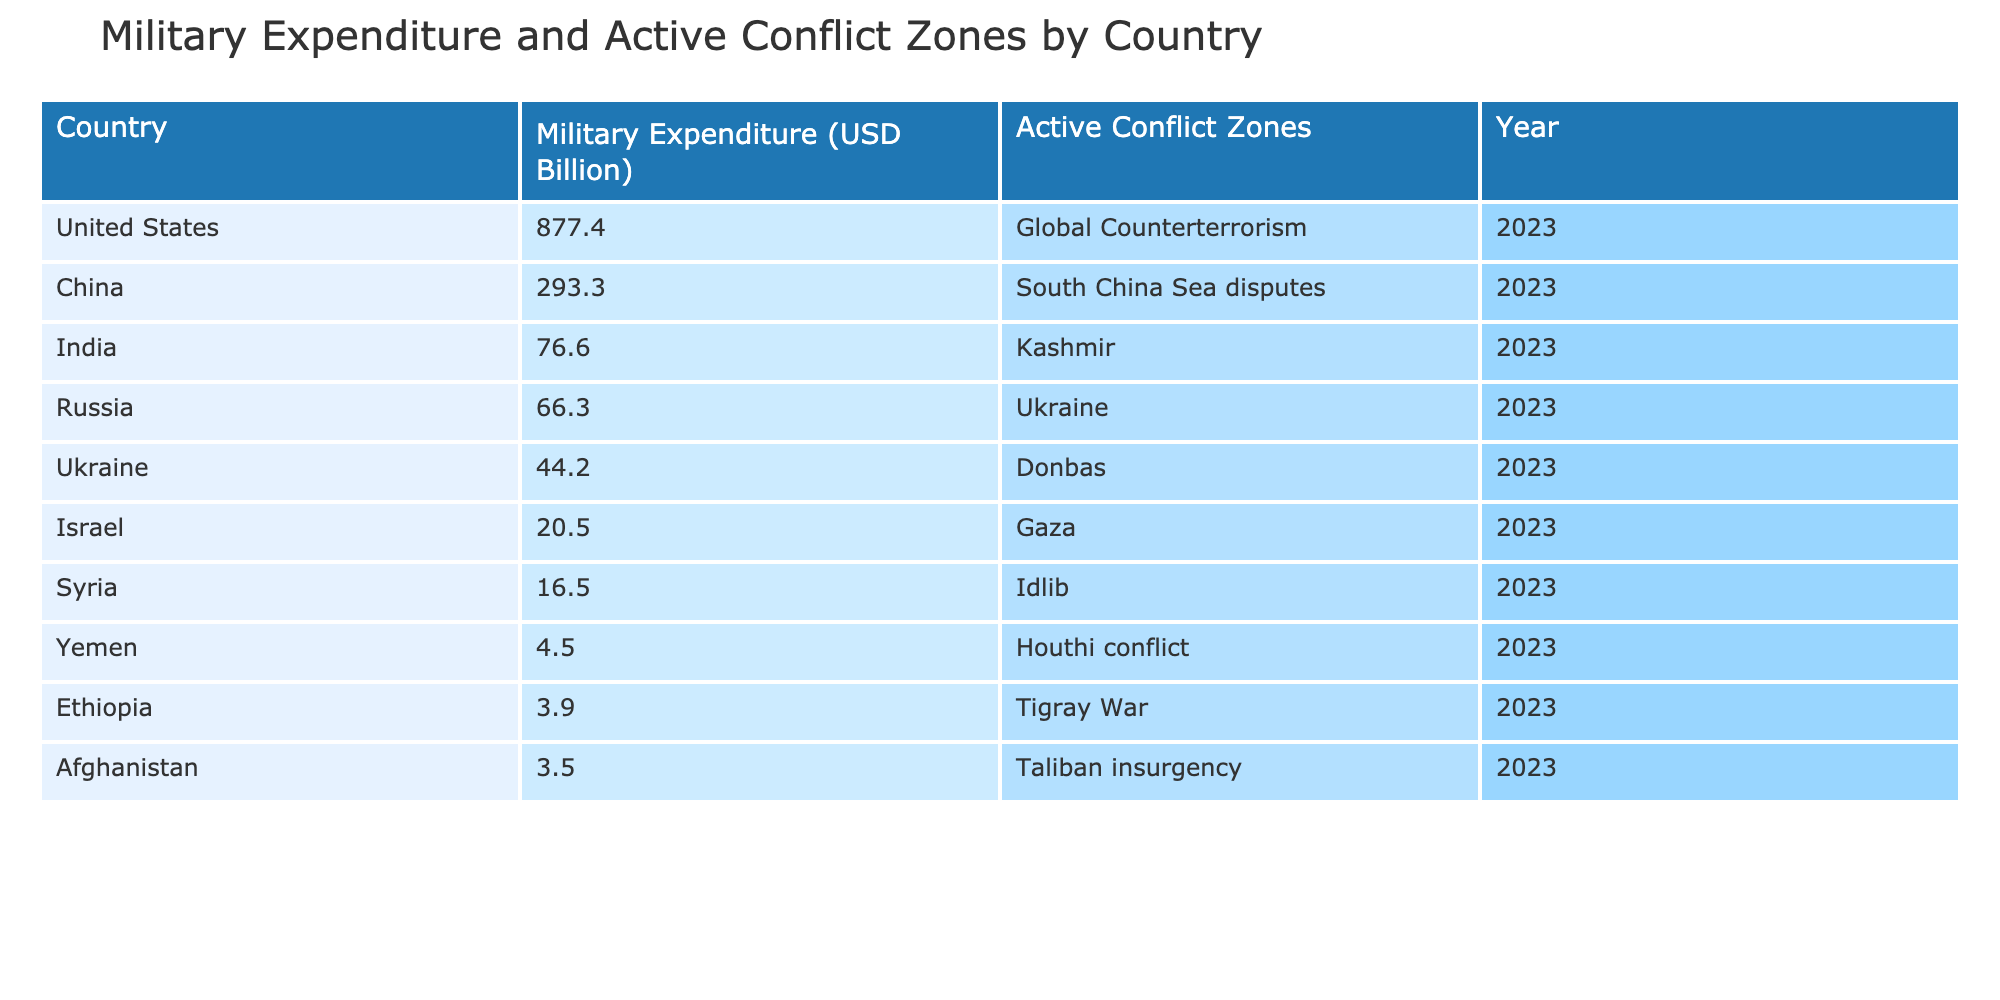What country has the highest military expenditure? The country with the highest military expenditure is the United States, with a figure of 877.4 billion USD. This value is retrieved directly from the table, identifying the maximum expenditure listed.
Answer: United States What is the military expenditure of Ukraine in 2023? Ukraine's military expenditure for the year 2023 is 44.2 billion USD, as can be found in the respective row of the table.
Answer: 44.2 billion USD How much more does China spend on military than Ethiopia? China's military expenditure is 293.3 billion USD, while Ethiopia's is 3.9 billion USD. The difference is calculated as 293.3 - 3.9 = 289.4 billion USD.
Answer: 289.4 billion USD Is Syria involved in an active conflict zone? Yes, Syria is involved in an active conflict zone, specifically in Idlib. This fact can be verified by reading the "Active Conflict Zones" column under Syria's entry in the table.
Answer: Yes What is the total military expenditure of the countries involved in the Yemen conflict? Only Yemen is listed as involved in the Houthi conflict, with a military expenditure of 4.5 billion USD. Since it is the only relevant country, the total expenditure is simply this value.
Answer: 4.5 billion USD What is the average military expenditure of the countries listed in the table? To find the average, sum the military expenditures: 44.2 + 66.3 + 16.5 + 877.4 + 3.5 + 4.5 + 20.5 + 3.9 + 76.6 + 293.3 = 1, 406.3 billion USD. There are 10 countries, therefore the average is 1,406.3 / 10 = 140.63 billion USD.
Answer: 140.63 billion USD Which country has the lowest military expenditure among the listed conflict zones? Among the countries listed, Afghanistan has the lowest military expenditure at 3.5 billion USD. This is determined by comparing all listed expenditures in the table and selecting the minimum.
Answer: Afghanistan Has India's military expenditure exceeded that of Russia? No, India's military expenditure of 76.6 billion USD does not exceed Russia's expenditure of 66.3 billion USD. This verification involves a simple comparison of the two values.
Answer: No What are the active conflict zones for the countries with the top three highest military expenditures? For the United States, the active conflict zone is Global Counterterrorism; for China, it is the South China Sea disputes; and for India, it is Kashmir. This information is gathered by correlating the military expenditure with their respective active conflict zones listed in the table.
Answer: Global Counterterrorism, South China Sea disputes, Kashmir 